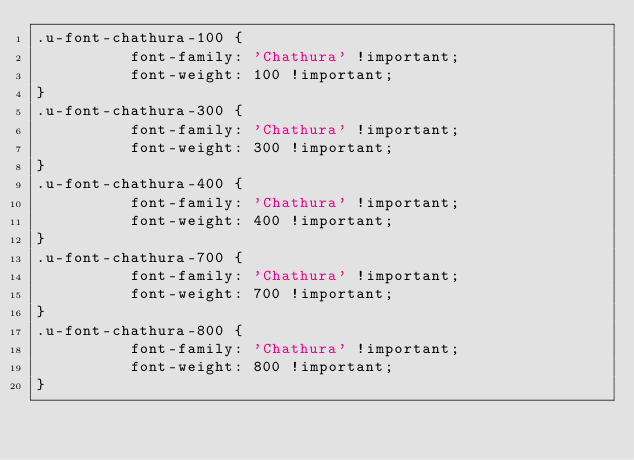<code> <loc_0><loc_0><loc_500><loc_500><_CSS_>.u-font-chathura-100 {
          font-family: 'Chathura' !important;
          font-weight: 100 !important;
}
.u-font-chathura-300 {
          font-family: 'Chathura' !important;
          font-weight: 300 !important;
}
.u-font-chathura-400 {
          font-family: 'Chathura' !important;
          font-weight: 400 !important;
}
.u-font-chathura-700 {
          font-family: 'Chathura' !important;
          font-weight: 700 !important;
}
.u-font-chathura-800 {
          font-family: 'Chathura' !important;
          font-weight: 800 !important;
}</code> 